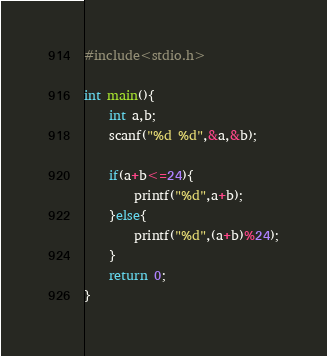<code> <loc_0><loc_0><loc_500><loc_500><_C_>#include<stdio.h>

int main(){
    int a,b;
    scanf("%d %d",&a,&b);

    if(a+b<=24){
        printf("%d",a+b);
    }else{
        printf("%d",(a+b)%24);
    }
    return 0;
}</code> 